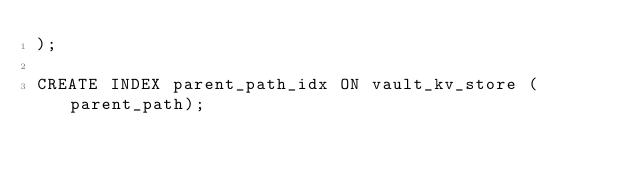<code> <loc_0><loc_0><loc_500><loc_500><_SQL_>);

CREATE INDEX parent_path_idx ON vault_kv_store (parent_path);
</code> 